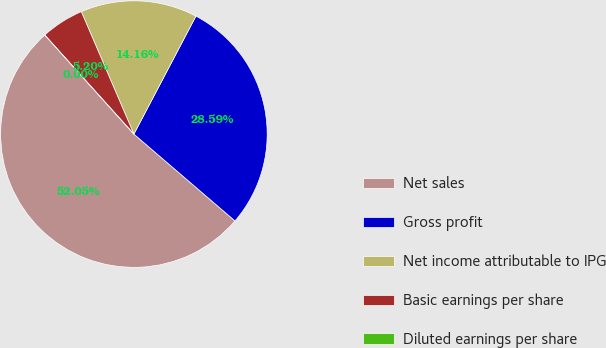<chart> <loc_0><loc_0><loc_500><loc_500><pie_chart><fcel>Net sales<fcel>Gross profit<fcel>Net income attributable to IPG<fcel>Basic earnings per share<fcel>Diluted earnings per share<nl><fcel>52.05%<fcel>28.59%<fcel>14.16%<fcel>5.2%<fcel>0.0%<nl></chart> 